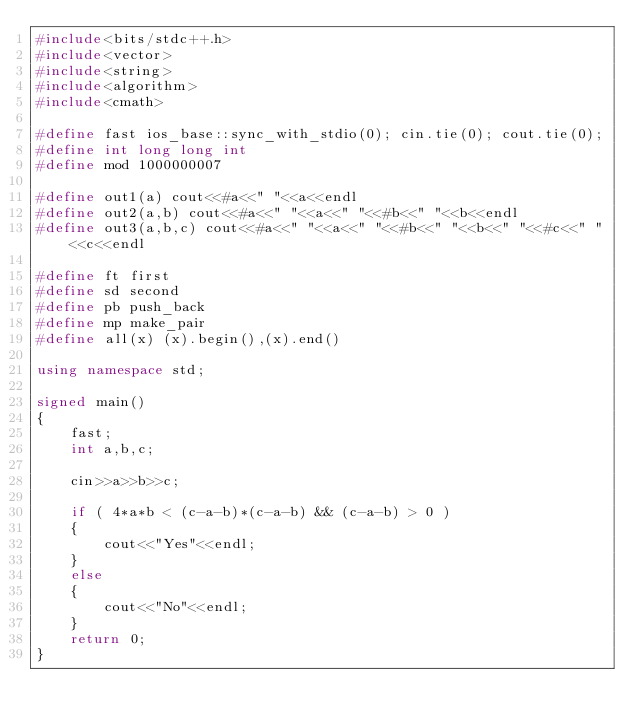<code> <loc_0><loc_0><loc_500><loc_500><_C++_>#include<bits/stdc++.h>
#include<vector>
#include<string>
#include<algorithm>
#include<cmath>
 
#define fast ios_base::sync_with_stdio(0); cin.tie(0); cout.tie(0);
#define int long long int
#define mod 1000000007

#define out1(a) cout<<#a<<" "<<a<<endl
#define out2(a,b) cout<<#a<<" "<<a<<" "<<#b<<" "<<b<<endl
#define out3(a,b,c) cout<<#a<<" "<<a<<" "<<#b<<" "<<b<<" "<<#c<<" "<<c<<endl

#define ft first
#define sd second
#define pb push_back
#define mp make_pair
#define all(x) (x).begin(),(x).end()
 
using namespace std;

signed main()
{
    fast;
    int a,b,c;

    cin>>a>>b>>c;

    if ( 4*a*b < (c-a-b)*(c-a-b) && (c-a-b) > 0 )
    {
        cout<<"Yes"<<endl;
    }
    else
    {
        cout<<"No"<<endl;
    }
    return 0;
}</code> 